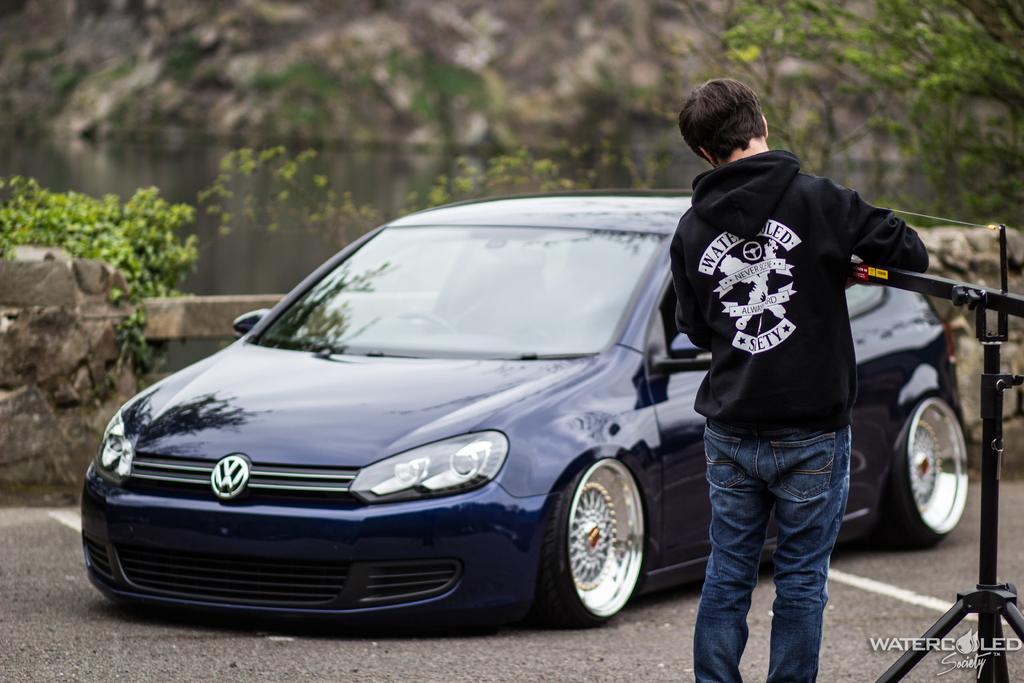Describe this image in one or two sentences. On the right side of the image we can see a man, he is holding a metal rod, in front of him we can find a car and few trees, in the bottom right hand corner we can see some text. 